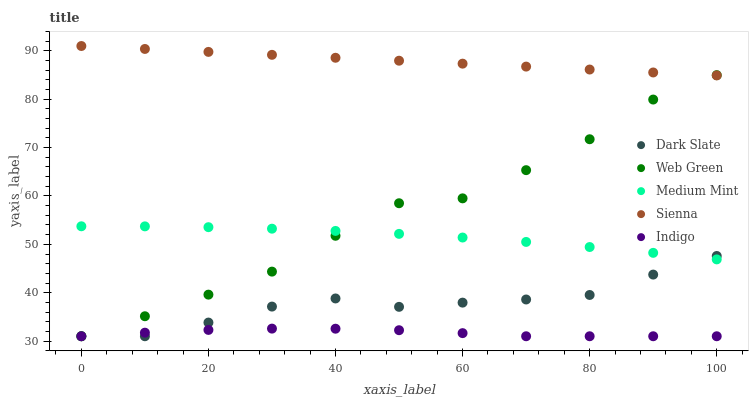Does Indigo have the minimum area under the curve?
Answer yes or no. Yes. Does Sienna have the maximum area under the curve?
Answer yes or no. Yes. Does Dark Slate have the minimum area under the curve?
Answer yes or no. No. Does Dark Slate have the maximum area under the curve?
Answer yes or no. No. Is Sienna the smoothest?
Answer yes or no. Yes. Is Web Green the roughest?
Answer yes or no. Yes. Is Dark Slate the smoothest?
Answer yes or no. No. Is Dark Slate the roughest?
Answer yes or no. No. Does Dark Slate have the lowest value?
Answer yes or no. Yes. Does Sienna have the lowest value?
Answer yes or no. No. Does Sienna have the highest value?
Answer yes or no. Yes. Does Dark Slate have the highest value?
Answer yes or no. No. Is Medium Mint less than Sienna?
Answer yes or no. Yes. Is Medium Mint greater than Indigo?
Answer yes or no. Yes. Does Medium Mint intersect Dark Slate?
Answer yes or no. Yes. Is Medium Mint less than Dark Slate?
Answer yes or no. No. Is Medium Mint greater than Dark Slate?
Answer yes or no. No. Does Medium Mint intersect Sienna?
Answer yes or no. No. 